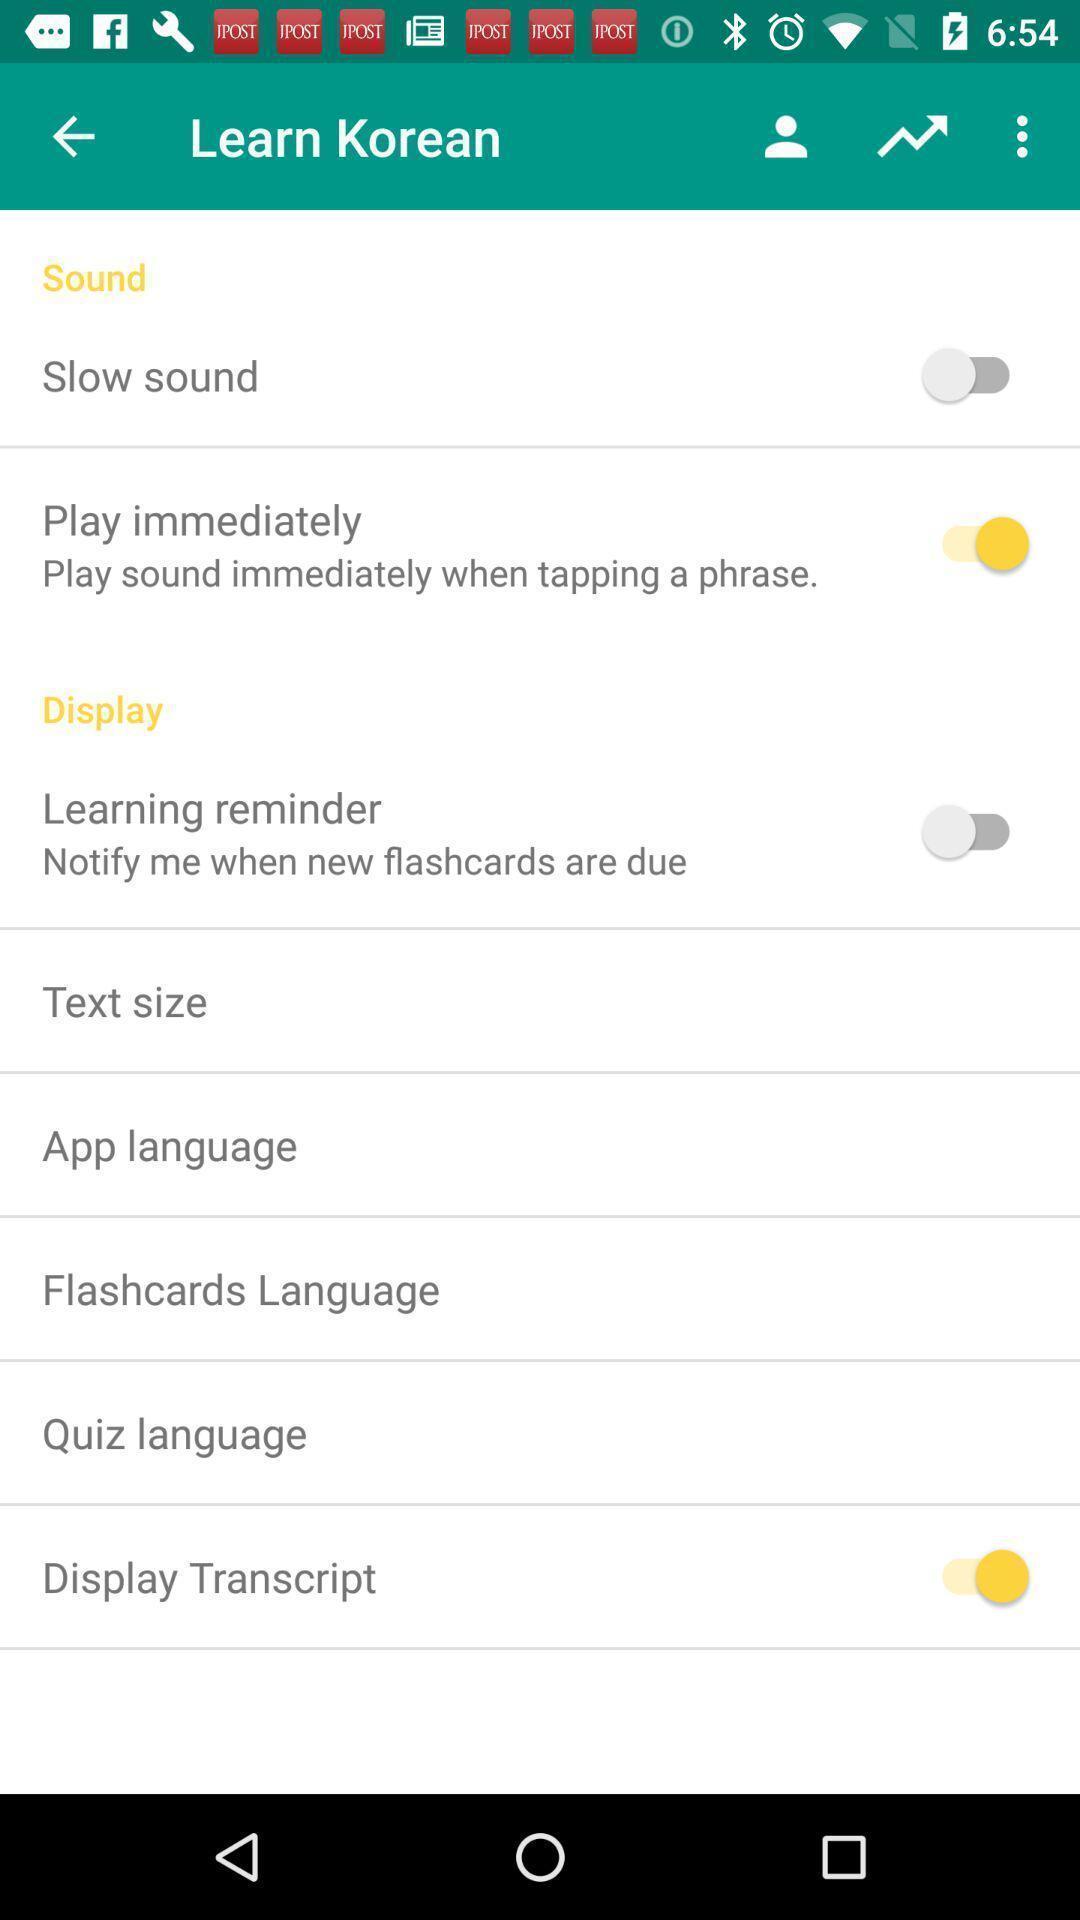What details can you identify in this image? Screen displaying multiple options in a language learning application. 